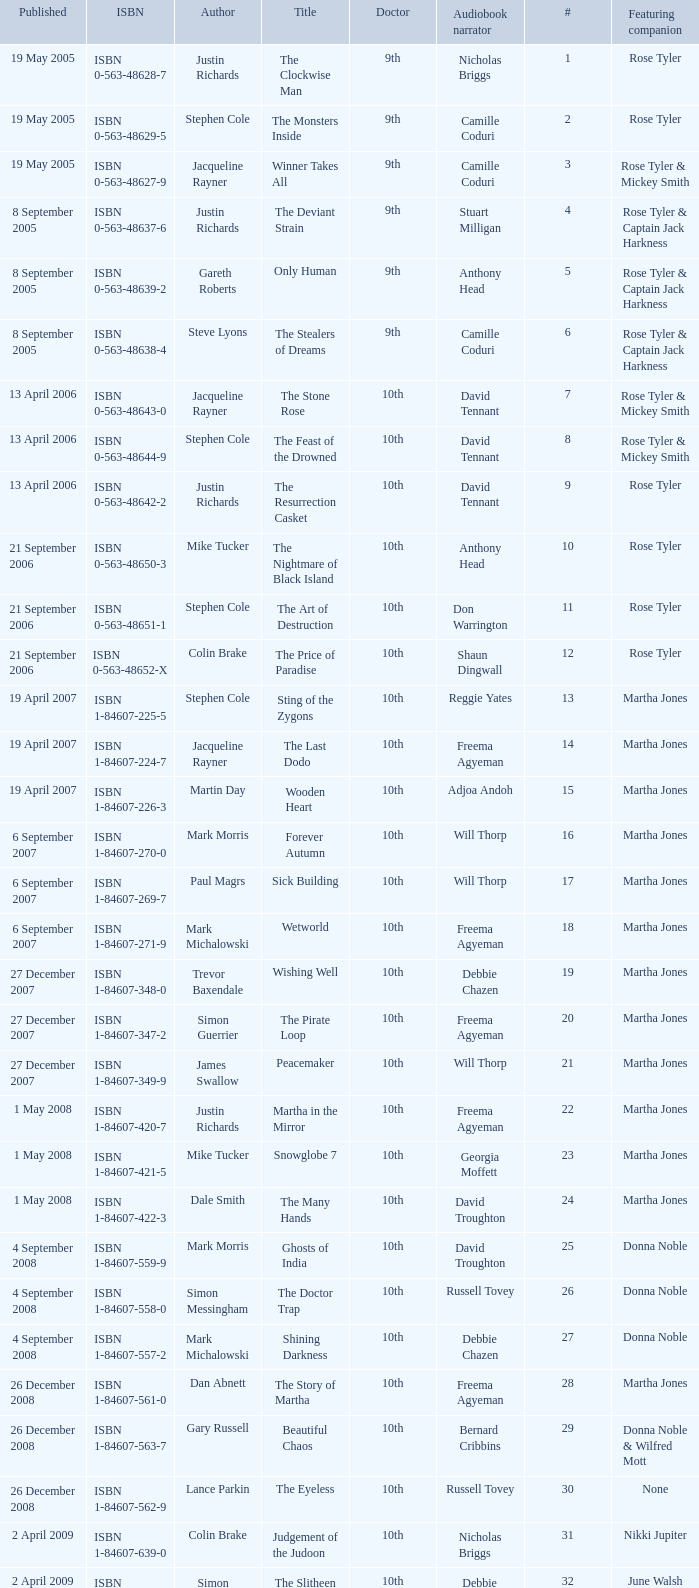What is the title of ISBN 1-84990-243-7? The Silent Stars Go By. 